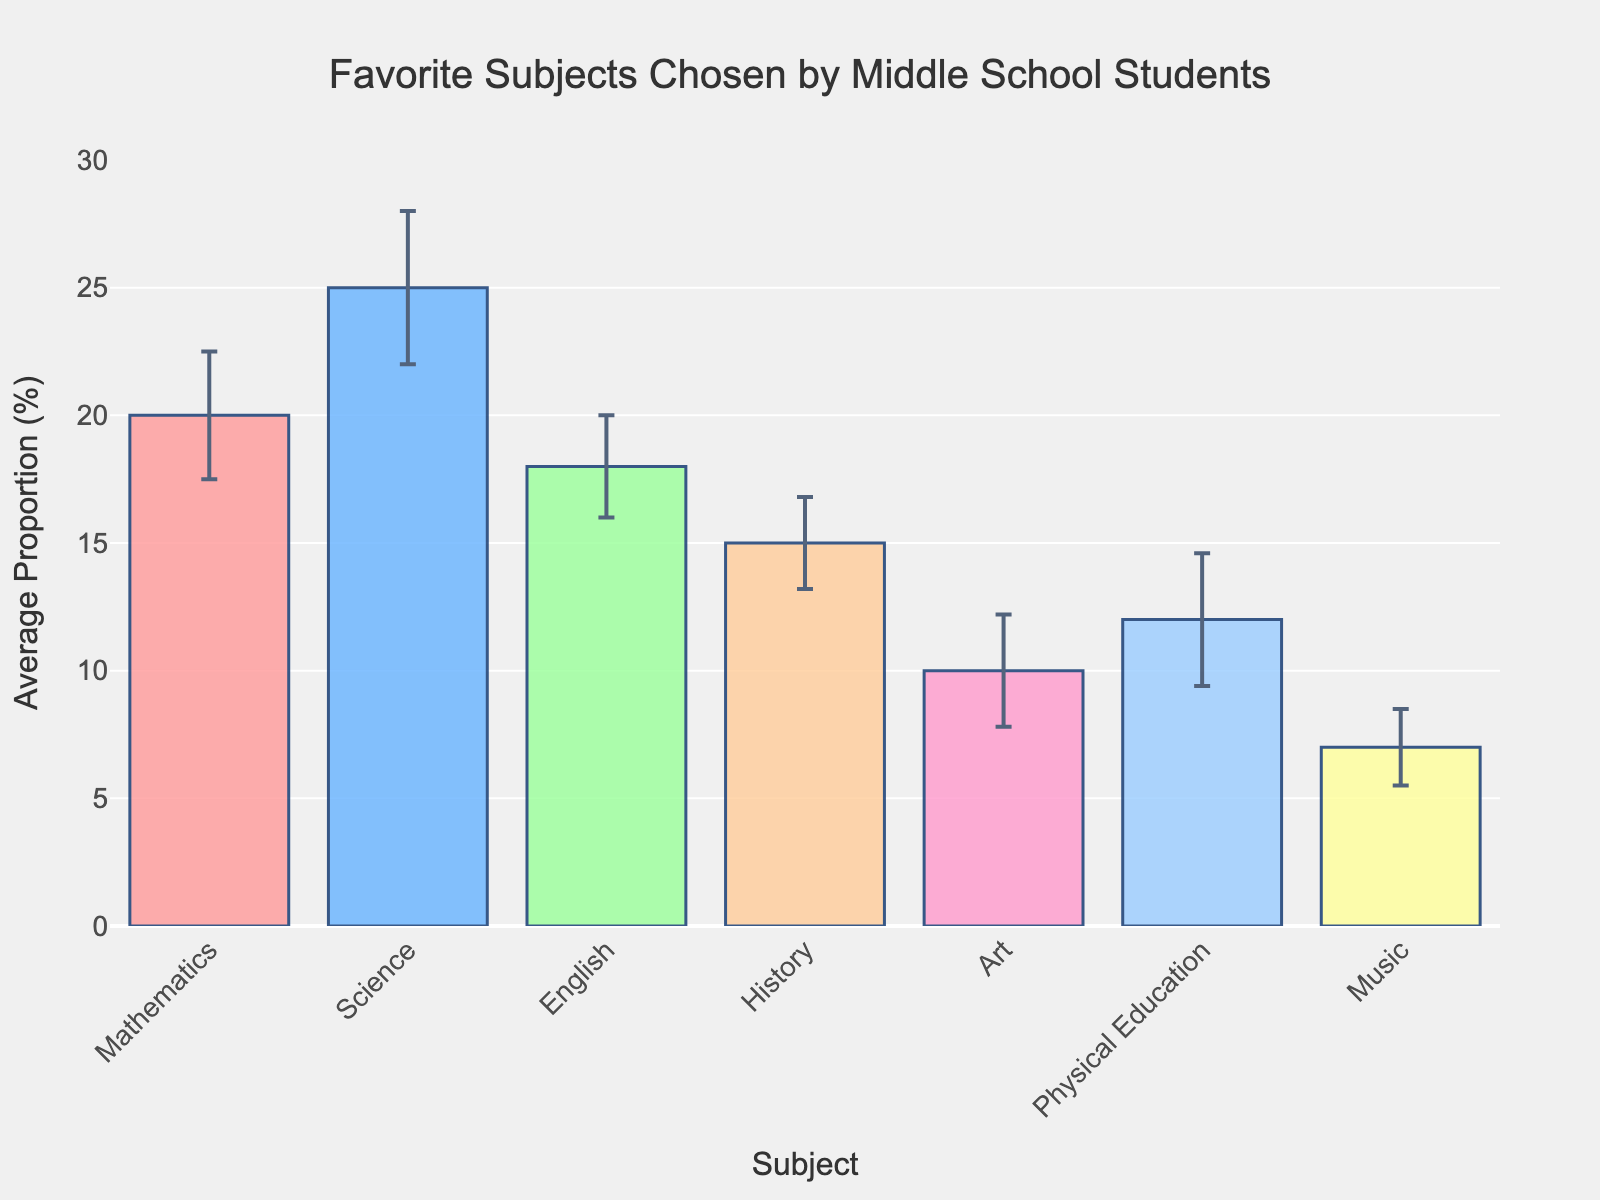What's the title of the chart? The title is located at the top of the chart. It reads, "Favorite Subjects Chosen by Middle School Students".
Answer: Favorite Subjects Chosen by Middle School Students What subject has the highest average proportion of middle school students liking it? To find this, look at the bars and their corresponding heights. The tallest bar represents the subject with the highest average proportion.
Answer: Science Which subject has the lowest average proportion of middle school students liking it? This is found by identifying the shortest bar in the chart. The shortest bar represents the subject with the lowest average proportion.
Answer: Music How much higher is the average proportion of students who like Science compared to those who like Mathematics? First, find the average proportion of students liking Science (25%) and Mathematics (20%). Subtract the latter from the former: 25% - 20% = 5%.
Answer: 5% What is the range of proportions for the subject with the largest variability? The largest variability is indicated by the longest error bar. Science has the highest standard deviation (3.0). The range is calculated as average ± standard deviation: 25% ± 3% produces a range of 22% to 28%.
Answer: 22% to 28% Which subject has the smallest error bar, indicating the least variability among student preferences? Examine the lengths of the error bars. The shortest error bar corresponds to Music with a standard deviation of 1.5%.
Answer: Music Compare the popularity of English and Physical Education. Which one is liked more, and by how much? Check the heights of the bars for English (18%) and Physical Education (12%). The difference in their popularity is 18% - 12% = 6%. English is liked more by 6%.
Answer: English by 6% What is the total average proportion of students who like either Art or Music? Add the average proportions of students liking Art (10%) and Music (7%). The total is 10% + 7% = 17%.
Answer: 17% Which subject has an average proportion closest to the middle value of all listed average proportions? The listed average proportions are 20%, 25%, 18%, 15%, 10%, 12%, and 7%. The middle value (median) is determined by arranging the numbers in ascending order and finding the middle. The median is 15%, corresponding to History.
Answer: History What are the upper and lower bounds for the average proportion of students who favor Physical Education? Calculate these bounds using the average proportion (12%) and the standard deviation (2.6%). The bounds are 12% ± 2.6% resulting in a range of 9.4% to 14.6%.
Answer: 9.4% to 14.6% 